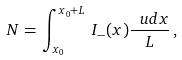<formula> <loc_0><loc_0><loc_500><loc_500>N = \, \int _ { x _ { 0 } } ^ { x _ { 0 } + L } \, I _ { - } ( x ) \frac { \ u d x } { L } \, ,</formula> 